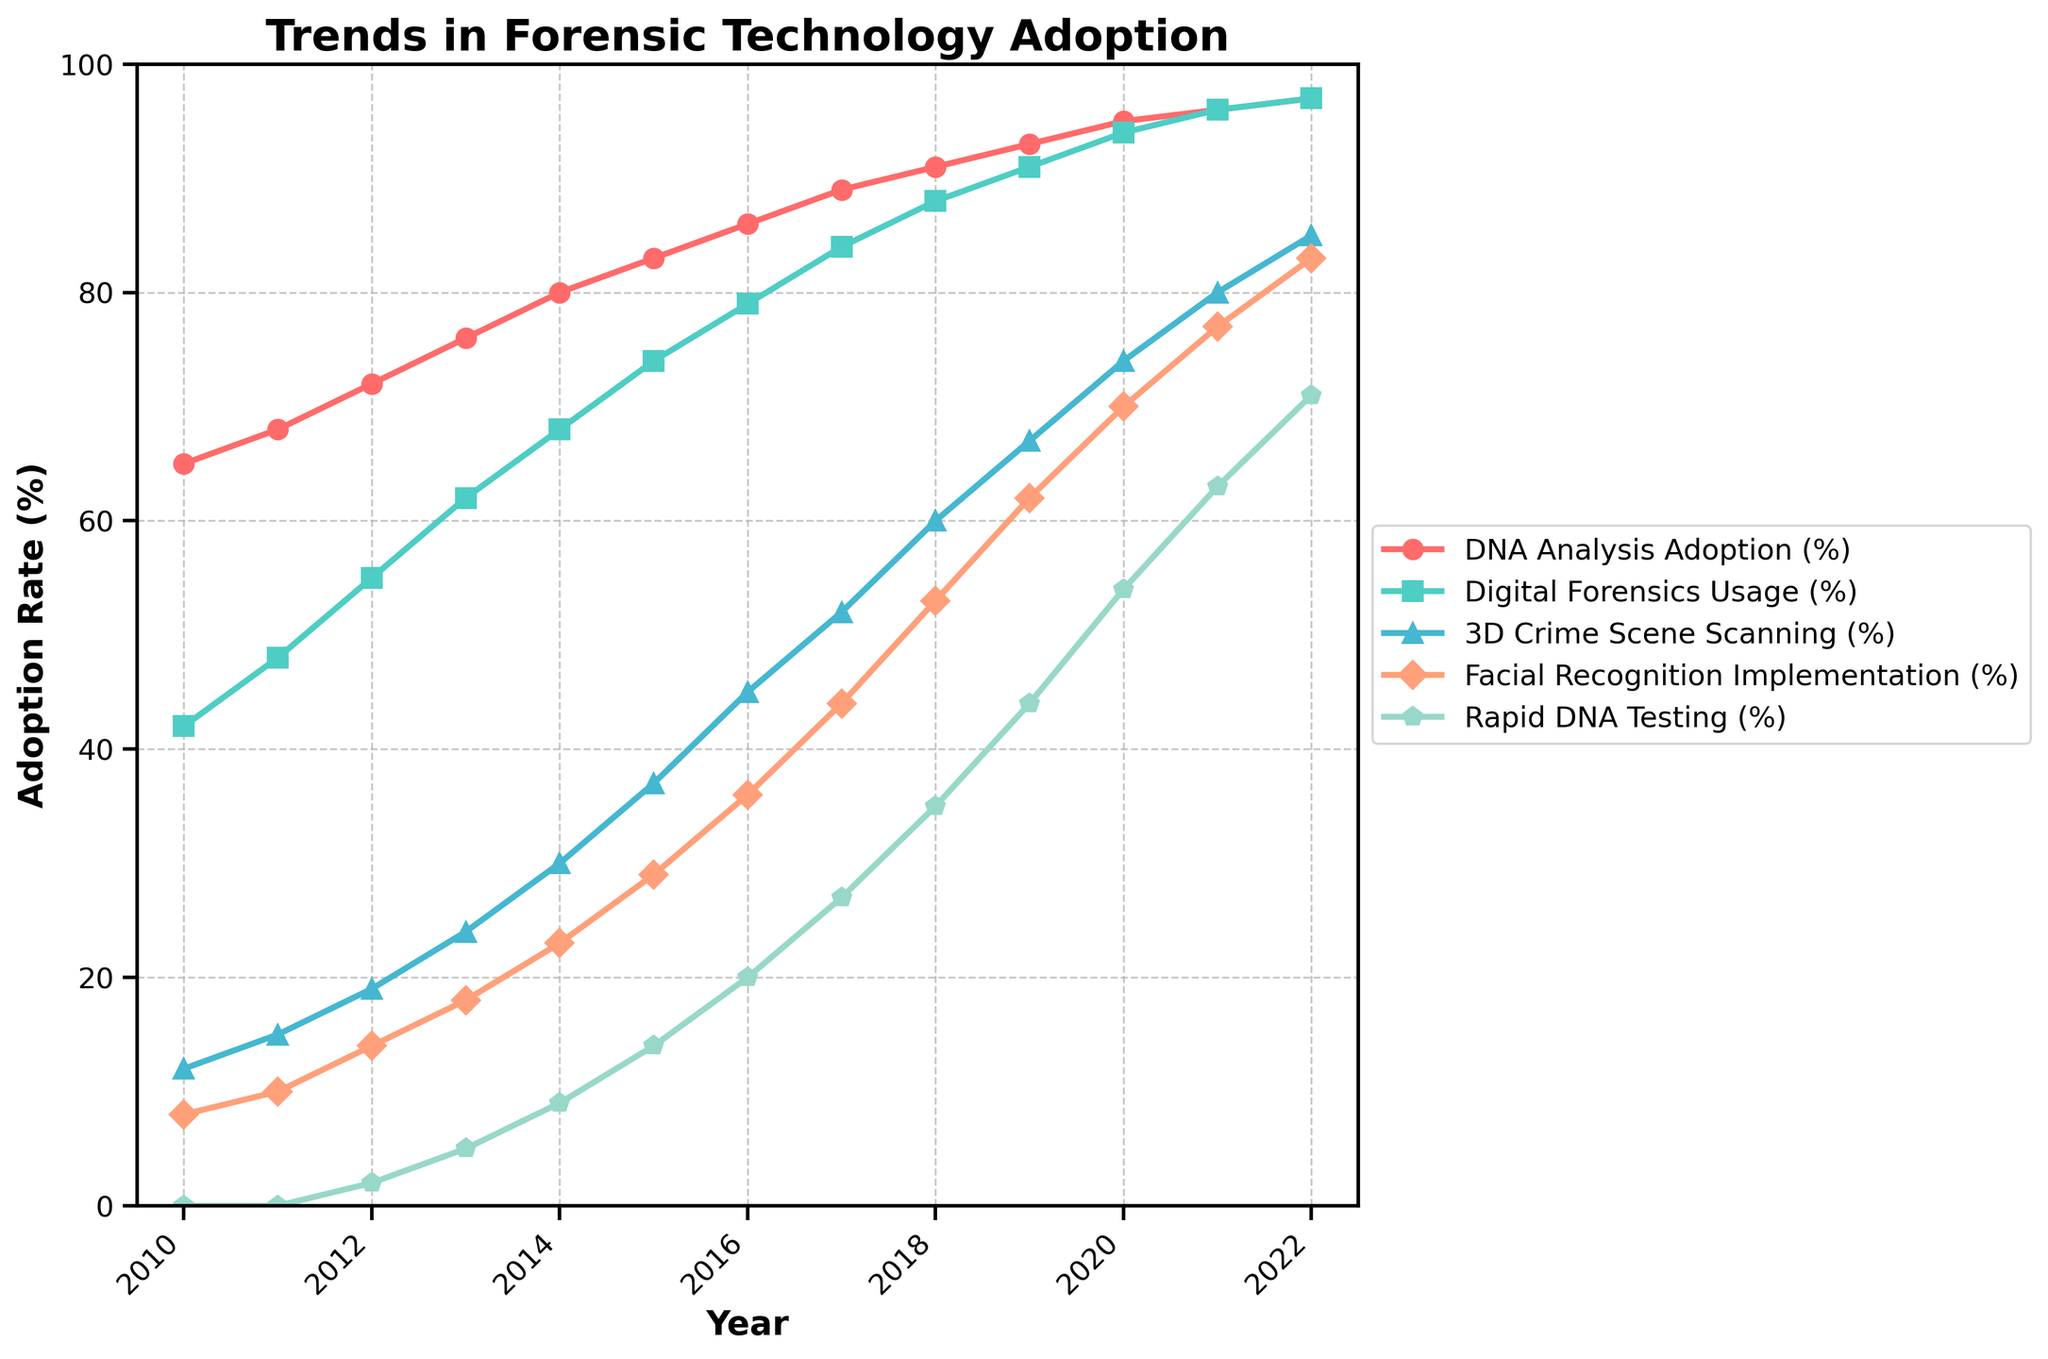What year did 3D Crime Scene Scanning surpass 20% adoption? To find out which year 3D Crime Scene Scanning surpassed 20% adoption, look along the y-axis for the 20% mark and track the trend line for 3D Crime Scene Scanning until it exceeds this value. According to the data, this happens in 2016.
Answer: 2016 Which forensic technology had the steepest increase in adoption from 2010 to 2015? Compare the slopes of the lines for each technology between 2010 and 2015. The steepest increases will have the greatest vertical difference between these years. DNA Analysis Adoption increased from 65% to 83%, Digital Forensics Usage from 42% to 74%, 3D Crime Scene Scanning from 12% to 37%, Facial Recognition Implementation from 8% to 29%, and Rapid DNA Testing from 0% to 14%. Digital Forensics Usage had the steepest increase.
Answer: Digital Forensics Usage By how much did Facial Recognition Implementation increase from 2014 to 2020? Find the adoption rates of Facial Recognition Implementation for both 2014 and 2020, and subtract the former from the latter. For 2014, it's 23% and for 2020, it's 70%. The increase is 70% - 23% = 47%.
Answer: 47% Which technology had the lowest adoption rate in 2012? Compare the adoption rates of all technologies in the year 2012. DNA Analysis is at 72%, Digital Forensics Usage is at 55%, 3D Crime Scene Scanning is at 19%, Facial Recognition Implementation is at 14%, and Rapid DNA Testing is at 2%. Rapid DNA Testing had the lowest adoption rate at 2%.
Answer: Rapid DNA Testing What is the average adoption rate of all technologies in 2022? Sum the adoption rates of all technologies for the year 2022 and divide by the total number of technologies. Adoption rates are: DNA Analysis 97%, Digital Forensics Usage 97%, 3D Crime Scene Scanning 85%, Facial Recognition Implementation 83%, and Rapid DNA Testing 71%. The average is (97+97+85+83+71) / 5 = 86.6%.
Answer: 86.6% In what years did Digital Forensics Usage match or exceed 50% adoption? Look at the trend line for Digital Forensics Usage and identify the years where the adoption rate is 50% or higher. Starting from the data, this was achieved in 2012 (55%) and onwards.
Answer: 2012 onwards By how many percentage points did Rapid DNA Testing adoption increase from 2011 to 2022? Find the adoption rate of Rapid DNA Testing for both 2011 and 2022, and subtract the former from the latter. For 2011, it's 0% and for 2022, it's 71%. The increase is 71% - 0% = 71%.
Answer: 71% Which technology had the highest adoption rate by 2021 and what was its value? Look at the adoption rates for each technology in 2021. DNA Analysis and Digital Forensics Usage both had the highest rate, at 96%.
Answer: DNA Analysis and Digital Forensics Usage, 96% Was there any technology that had a constant adoption rate early in the timeline? If so, which one and during which years? Check the lines for any technology that shows a flat trend early in the graph. Rapid DNA Testing had an adoption rate of 0% from 2010 to 2011.
Answer: Rapid DNA Testing, 2010-2011 